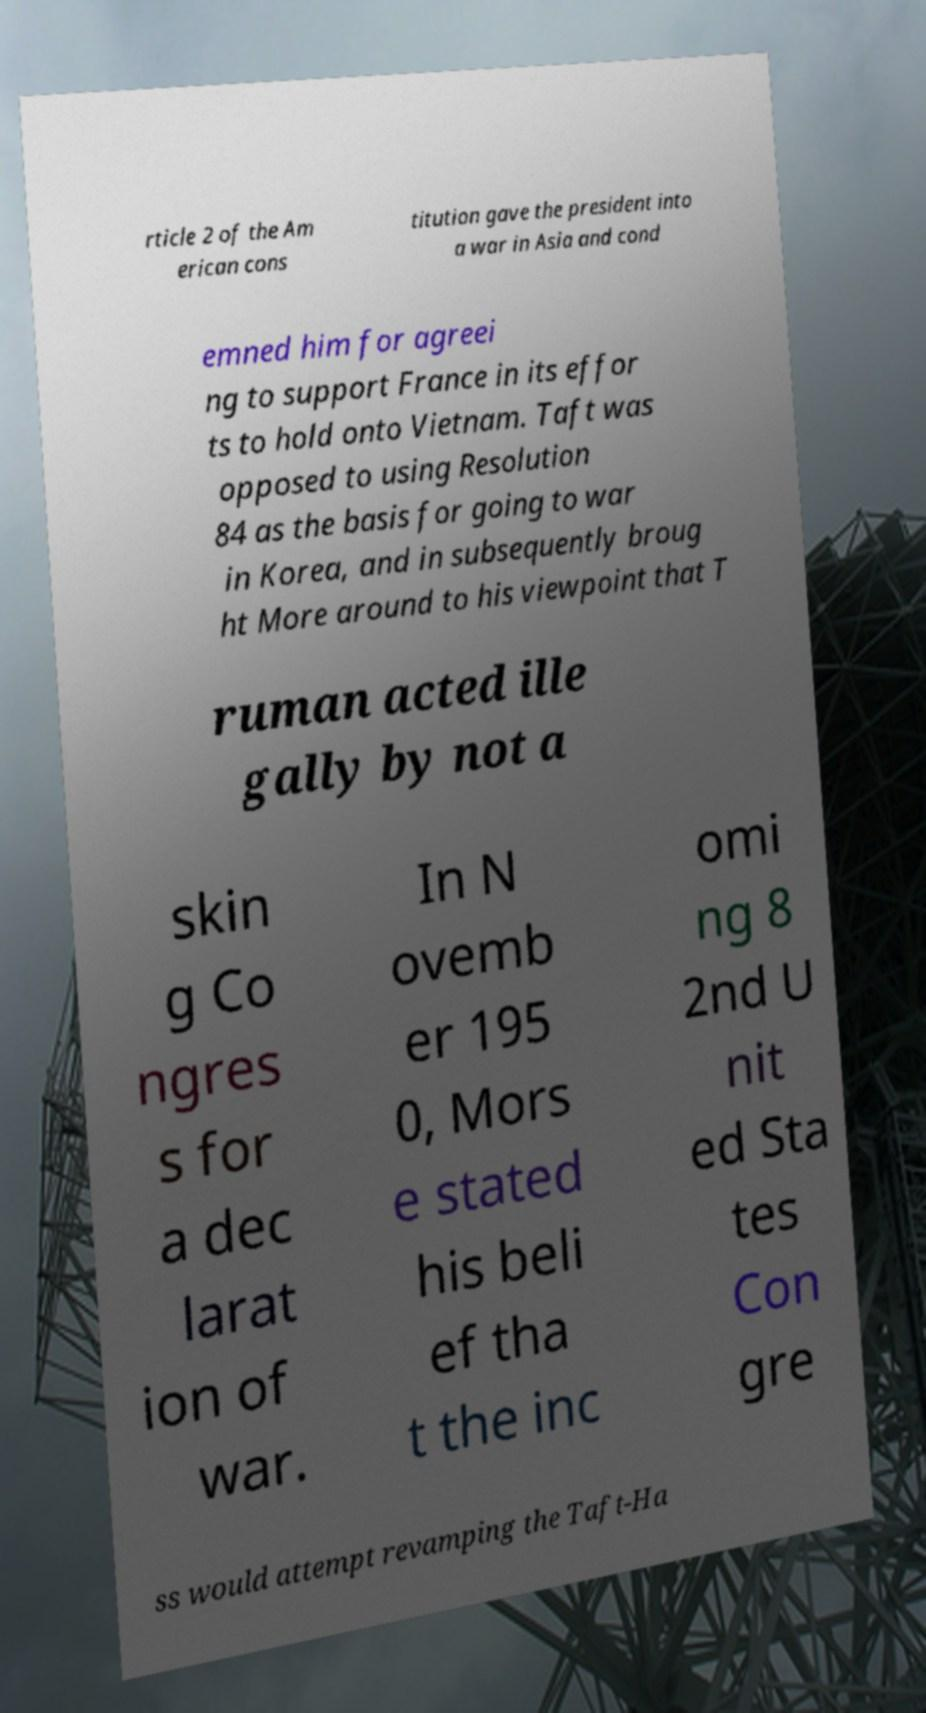Please identify and transcribe the text found in this image. rticle 2 of the Am erican cons titution gave the president into a war in Asia and cond emned him for agreei ng to support France in its effor ts to hold onto Vietnam. Taft was opposed to using Resolution 84 as the basis for going to war in Korea, and in subsequently broug ht More around to his viewpoint that T ruman acted ille gally by not a skin g Co ngres s for a dec larat ion of war. In N ovemb er 195 0, Mors e stated his beli ef tha t the inc omi ng 8 2nd U nit ed Sta tes Con gre ss would attempt revamping the Taft-Ha 